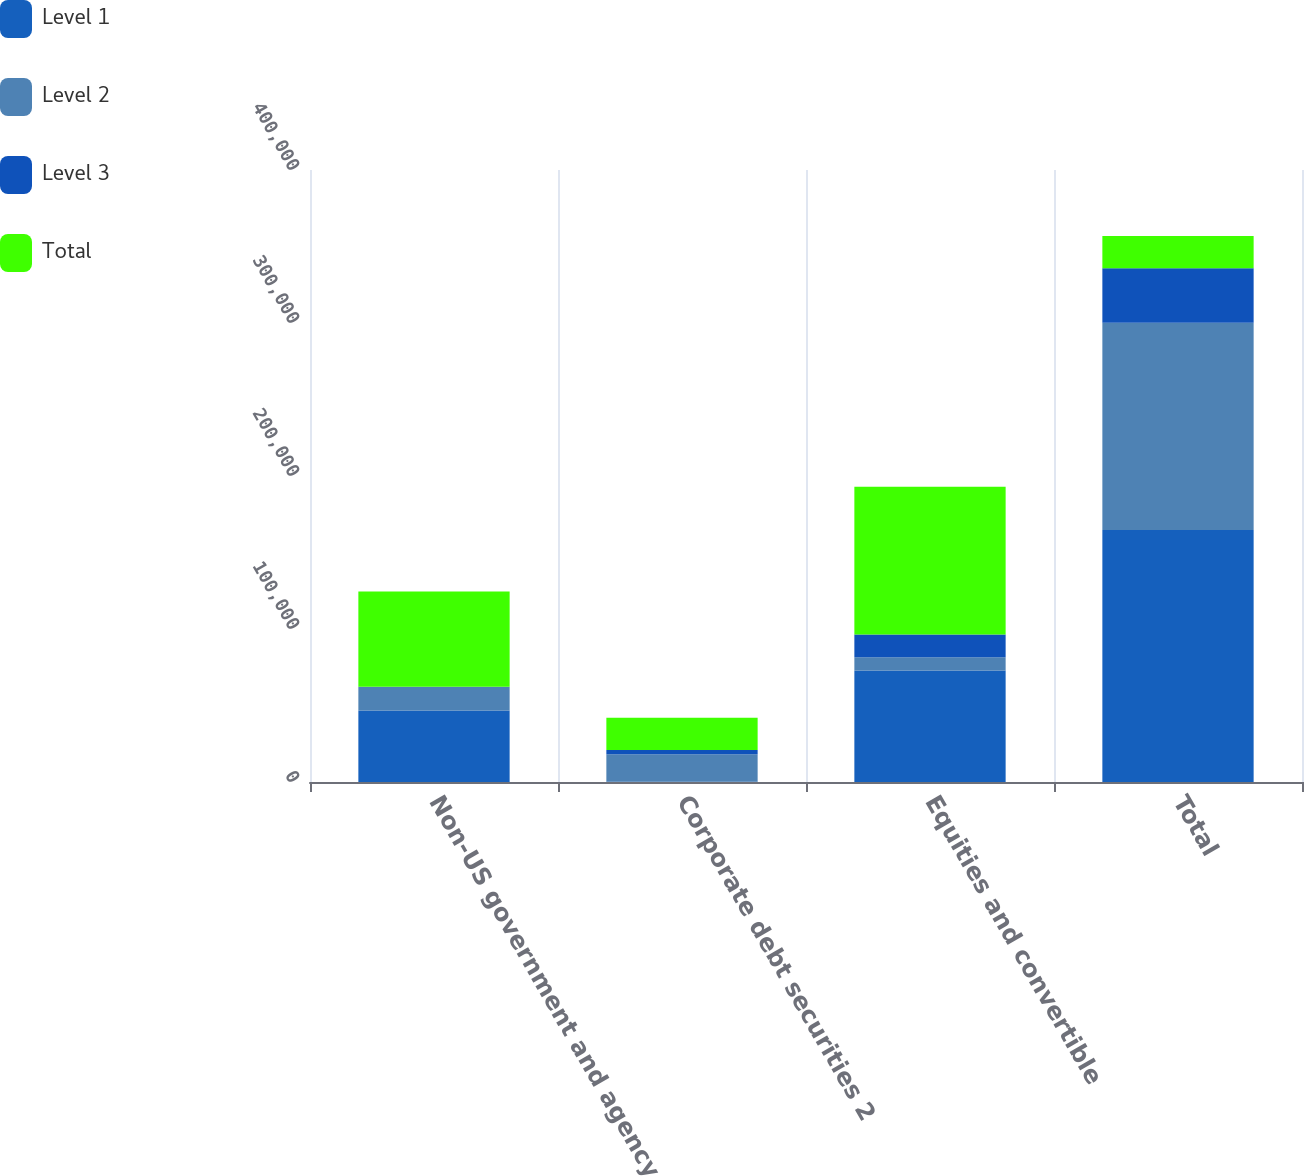Convert chart to OTSL. <chart><loc_0><loc_0><loc_500><loc_500><stacked_bar_chart><ecel><fcel>Non-US government and agency<fcel>Corporate debt securities 2<fcel>Equities and convertible<fcel>Total<nl><fcel>Level 1<fcel>46715<fcel>111<fcel>72875<fcel>164712<nl><fcel>Level 2<fcel>15509<fcel>18049<fcel>8724<fcel>135374<nl><fcel>Level 3<fcel>26<fcel>2821<fcel>14855<fcel>35749<nl><fcel>Total<fcel>62250<fcel>20981<fcel>96454<fcel>20981<nl></chart> 